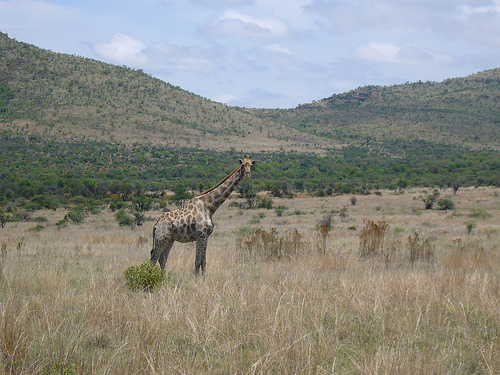<image>
Is there a bush next to the grass? Yes. The bush is positioned adjacent to the grass, located nearby in the same general area. 